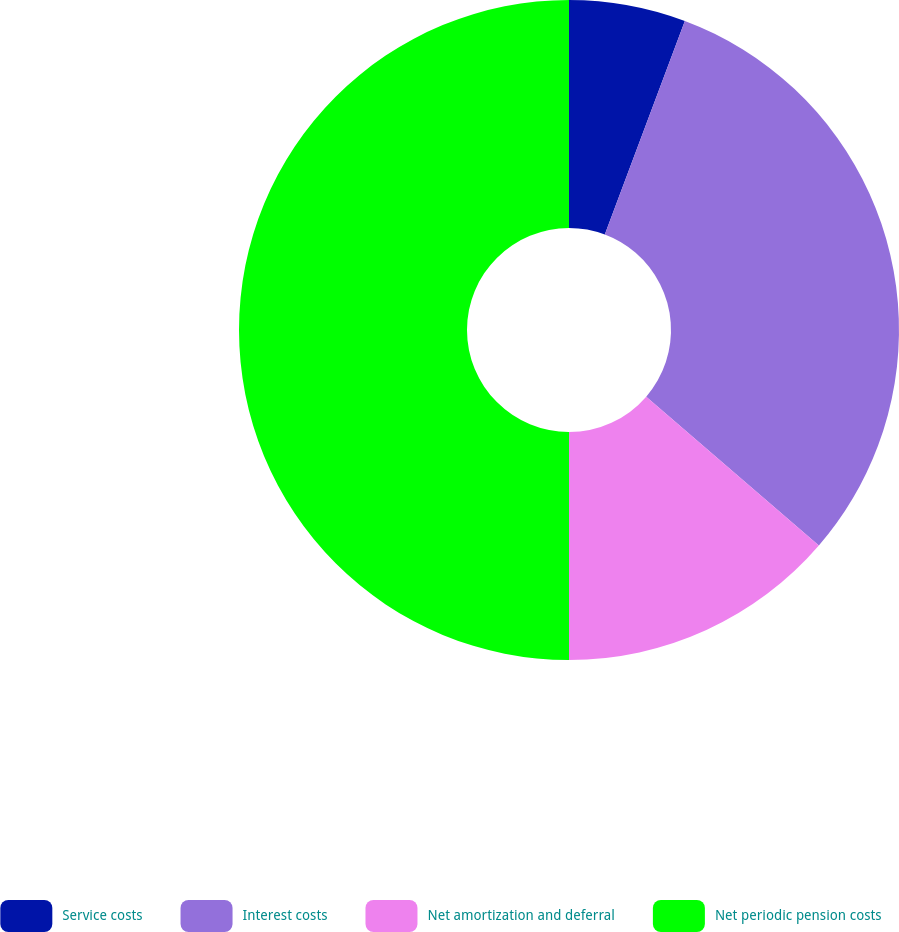Convert chart to OTSL. <chart><loc_0><loc_0><loc_500><loc_500><pie_chart><fcel>Service costs<fcel>Interest costs<fcel>Net amortization and deferral<fcel>Net periodic pension costs<nl><fcel>5.71%<fcel>30.62%<fcel>13.67%<fcel>50.0%<nl></chart> 